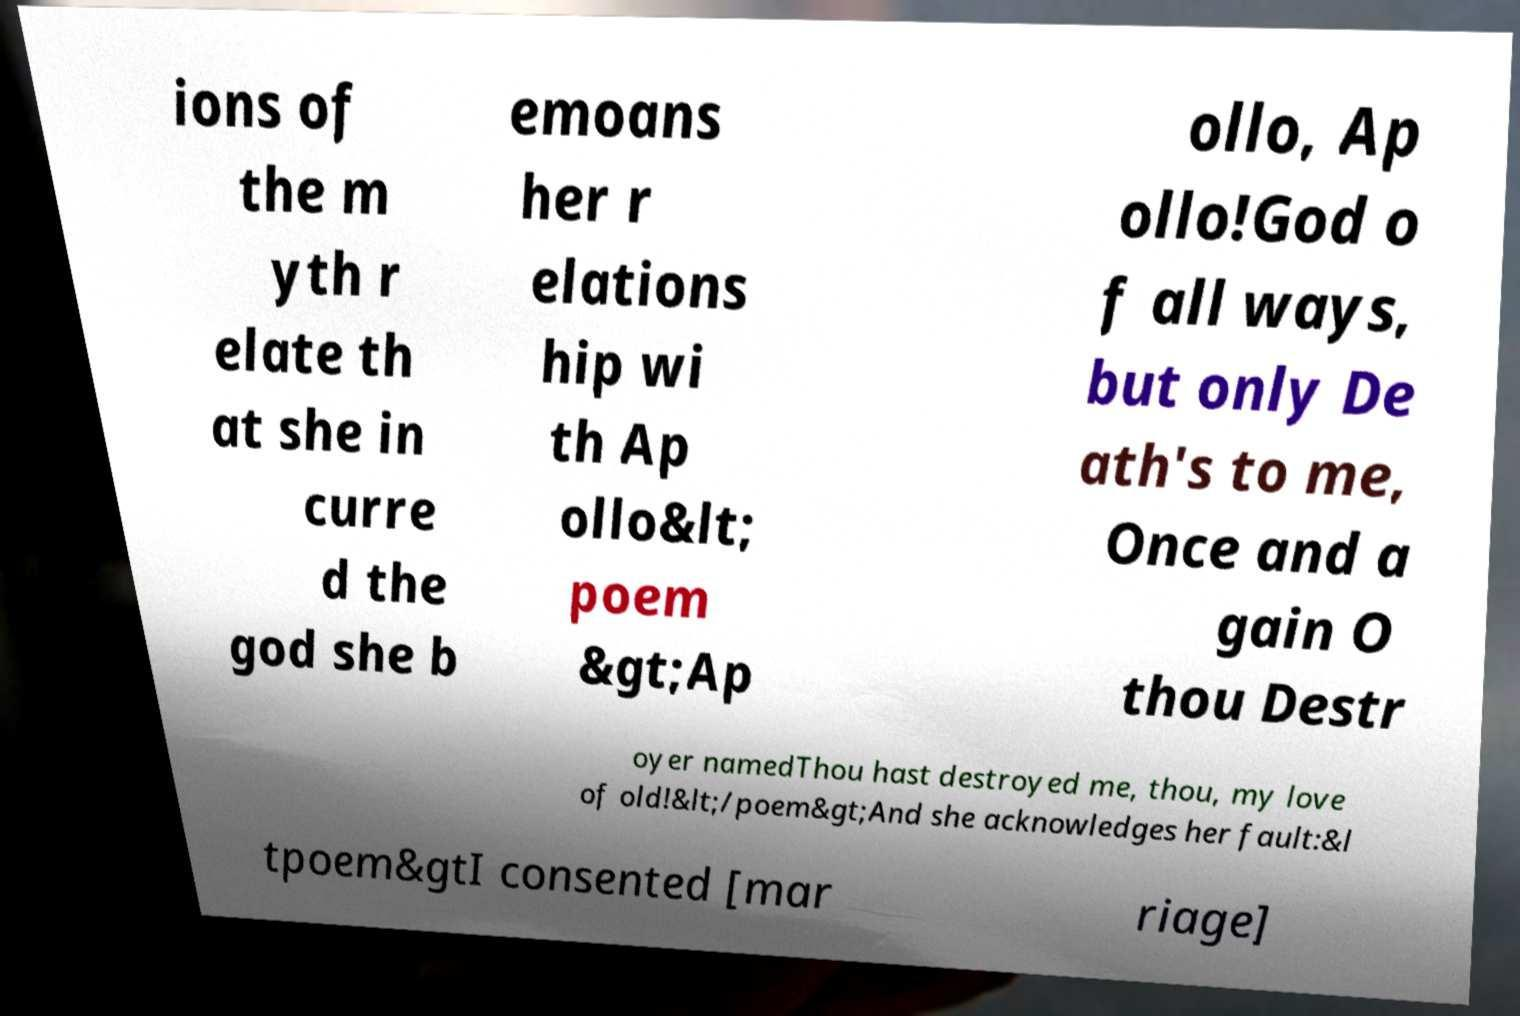What messages or text are displayed in this image? I need them in a readable, typed format. ions of the m yth r elate th at she in curre d the god she b emoans her r elations hip wi th Ap ollo&lt; poem &gt;Ap ollo, Ap ollo!God o f all ways, but only De ath's to me, Once and a gain O thou Destr oyer namedThou hast destroyed me, thou, my love of old!&lt;/poem&gt;And she acknowledges her fault:&l tpoem&gtI consented [mar riage] 